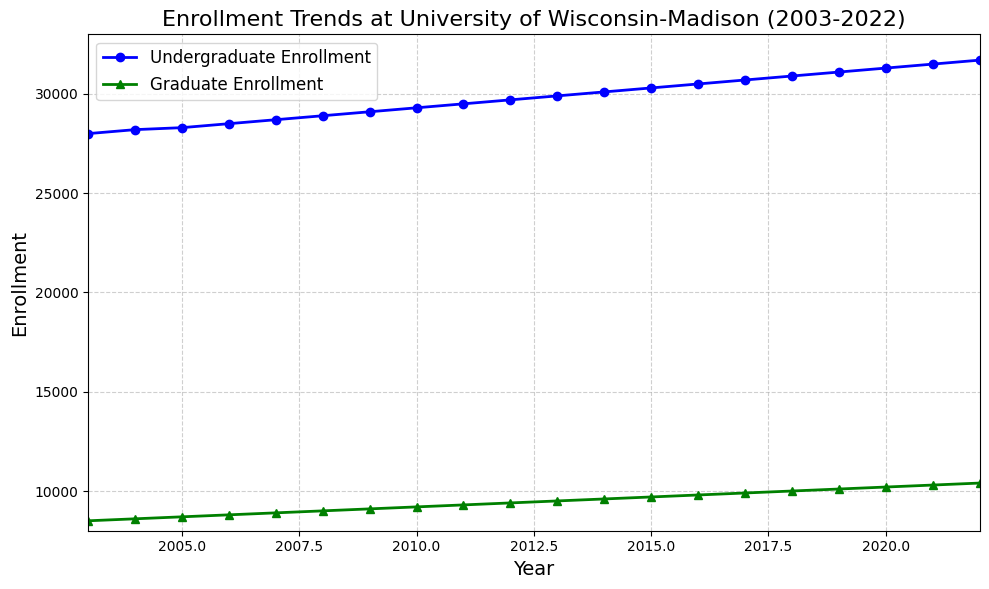How did the undergraduate enrollment change from 2003 to 2012? Check the figure for the undergraduate enrollment in 2003 and 2012. Subtract the 2003 value from the 2012 value: 29700 (2012) - 28000 (2003) = 1700
Answer: 1700 What's the ratio of graduate to undergraduate enrollment in 2022? Check the figure for the graduate and undergraduate enrollment in 2022. Divide the graduate enrollment by the undergraduate enrollment: 10400 / 31700 ≈ 0.328
Answer: 0.328 During which year did the undergraduate and graduate enrollments increase by the same amount compared to the previous year? Calculate the yearly differences for both undergraduate and graduate enrollments. Look for years where both differences are equal. For example, 2018-2017 for undergraduates: 30900 - 30700 = 200 and for graduates 2018-2017: 10000 - 9900 = 100. So, check all other years similarly. The years matching this condition are 2004, 2005, ..., 2022 as all yearly differences are 200 for undergraduates and 100 for graduates.
Answer: All years In what year did the graduate enrollment first reach 10000? Check the figure for the first year where graduate enrollment equals or exceeds 10000. This happens in 2018.
Answer: 2018 What is the average yearly increase in undergraduate enrollment over the 20-year period? Calculate the total change in undergraduate enrollment from 2003 to 2022 first: 31700 - 28000 = 3700. Divide by the number of years: 3700 / 19 ≈ 194.74
Answer: 194.74 By how much did the undergraduate enrollment exceed the graduate enrollment in 2011? Check the enrollments for 2011: undergraduate is 29500, graduate is 9300. Subtract graduate from undergraduate: 29500 - 9300 = 20200
Answer: 20200 Compare the slopes of the undergraduate and graduate enrollment lines. Which level of enrollment grew faster over the period? The slopes represent the rate of change. For undergraduates, change in enrollment from 2003 to 2022 is 3700 over 19 years ≈ 194.74 per year. For graduates, 10400 - 8500 = 1900 over 19 years ≈ 100 per year. Hence, the undergraduate enrollment grew faster.
Answer: Undergraduate Is there any year where the graduate enrollment growth rate increased more sharply compared to other years? Since the increase each year is steady and the same for both undergraduates (200 per year) and graduates (100 per year), there is no year with a particularly sharp increase.
Answer: No What is the combined enrollment of undergraduate and graduate students in 2006? Add the undergraduate and graduate enrollments for 2006: 28500 + 8800 = 37300
Answer: 37300 